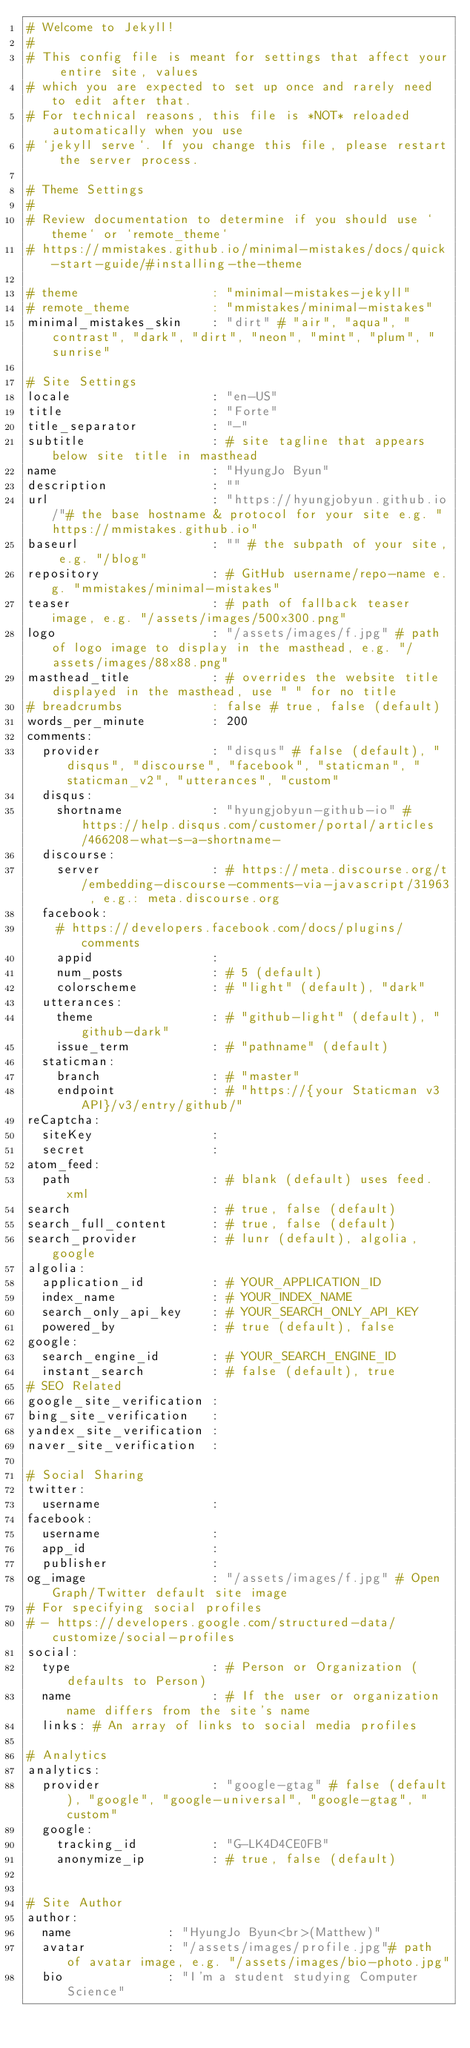Convert code to text. <code><loc_0><loc_0><loc_500><loc_500><_YAML_># Welcome to Jekyll!
#
# This config file is meant for settings that affect your entire site, values
# which you are expected to set up once and rarely need to edit after that.
# For technical reasons, this file is *NOT* reloaded automatically when you use
# `jekyll serve`. If you change this file, please restart the server process.

# Theme Settings
#
# Review documentation to determine if you should use `theme` or `remote_theme`
# https://mmistakes.github.io/minimal-mistakes/docs/quick-start-guide/#installing-the-theme

# theme                  : "minimal-mistakes-jekyll"
# remote_theme           : "mmistakes/minimal-mistakes"
minimal_mistakes_skin    : "dirt" # "air", "aqua", "contrast", "dark", "dirt", "neon", "mint", "plum", "sunrise"

# Site Settings
locale                   : "en-US"
title                    : "Forte"
title_separator          : "-"
subtitle                 : # site tagline that appears below site title in masthead
name                     : "HyungJo Byun"
description              : ""
url                      : "https://hyungjobyun.github.io/"# the base hostname & protocol for your site e.g. "https://mmistakes.github.io"
baseurl                  : "" # the subpath of your site, e.g. "/blog"
repository               : # GitHub username/repo-name e.g. "mmistakes/minimal-mistakes"
teaser                   : # path of fallback teaser image, e.g. "/assets/images/500x300.png"
logo                     : "/assets/images/f.jpg" # path of logo image to display in the masthead, e.g. "/assets/images/88x88.png"
masthead_title           : # overrides the website title displayed in the masthead, use " " for no title
# breadcrumbs            : false # true, false (default)
words_per_minute         : 200
comments:
  provider               : "disqus" # false (default), "disqus", "discourse", "facebook", "staticman", "staticman_v2", "utterances", "custom"
  disqus:
    shortname            : "hyungjobyun-github-io" # https://help.disqus.com/customer/portal/articles/466208-what-s-a-shortname-
  discourse:
    server               : # https://meta.discourse.org/t/embedding-discourse-comments-via-javascript/31963 , e.g.: meta.discourse.org
  facebook:
    # https://developers.facebook.com/docs/plugins/comments
    appid                :
    num_posts            : # 5 (default)
    colorscheme          : # "light" (default), "dark"
  utterances:
    theme                : # "github-light" (default), "github-dark"
    issue_term           : # "pathname" (default)
  staticman:
    branch               : # "master"
    endpoint             : # "https://{your Staticman v3 API}/v3/entry/github/"
reCaptcha:
  siteKey                :
  secret                 :
atom_feed:
  path                   : # blank (default) uses feed.xml
search                   : # true, false (default)
search_full_content      : # true, false (default)
search_provider          : # lunr (default), algolia, google
algolia:
  application_id         : # YOUR_APPLICATION_ID
  index_name             : # YOUR_INDEX_NAME
  search_only_api_key    : # YOUR_SEARCH_ONLY_API_KEY
  powered_by             : # true (default), false
google:
  search_engine_id       : # YOUR_SEARCH_ENGINE_ID
  instant_search         : # false (default), true
# SEO Related
google_site_verification :
bing_site_verification   :
yandex_site_verification :
naver_site_verification  :

# Social Sharing
twitter:
  username               :
facebook:
  username               :
  app_id                 :
  publisher              :
og_image                 : "/assets/images/f.jpg" # Open Graph/Twitter default site image
# For specifying social profiles
# - https://developers.google.com/structured-data/customize/social-profiles
social:
  type                   : # Person or Organization (defaults to Person)
  name                   : # If the user or organization name differs from the site's name
  links: # An array of links to social media profiles

# Analytics
analytics:
  provider               : "google-gtag" # false (default), "google", "google-universal", "google-gtag", "custom"
  google:
    tracking_id          : "G-LK4D4CE0FB"
    anonymize_ip         : # true, false (default)


# Site Author
author:
  name             : "HyungJo Byun<br>(Matthew)"
  avatar           : "/assets/images/profile.jpg"# path of avatar image, e.g. "/assets/images/bio-photo.jpg"
  bio              : "I'm a student studying Computer Science"</code> 